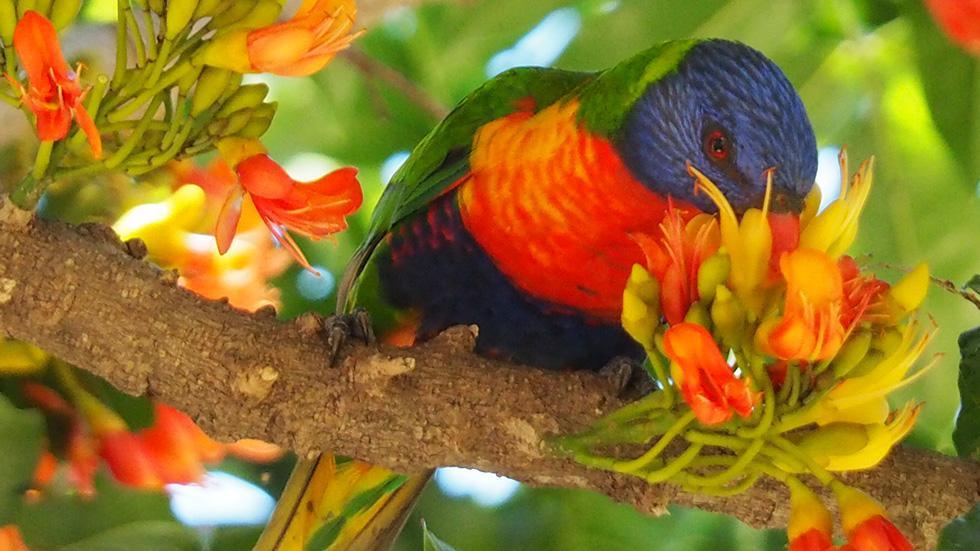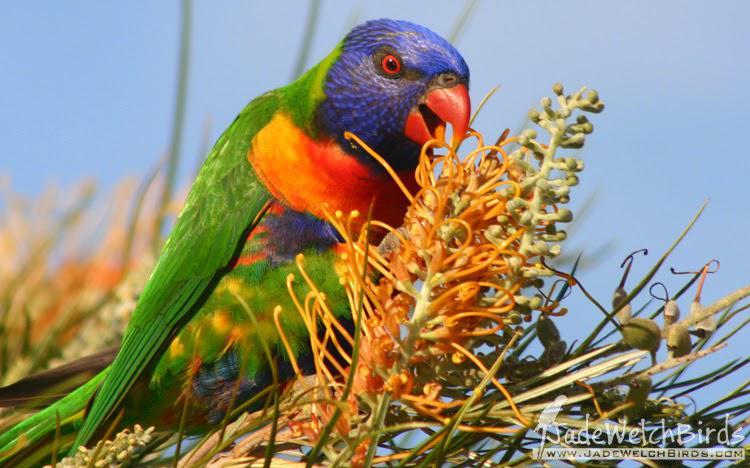The first image is the image on the left, the second image is the image on the right. Analyze the images presented: Is the assertion "In the image to the left, the bird is eating from a flower." valid? Answer yes or no. Yes. The first image is the image on the left, the second image is the image on the right. Examine the images to the left and right. Is the description "There is a total of 1 parrot perched on magenta colored flowers." accurate? Answer yes or no. No. 